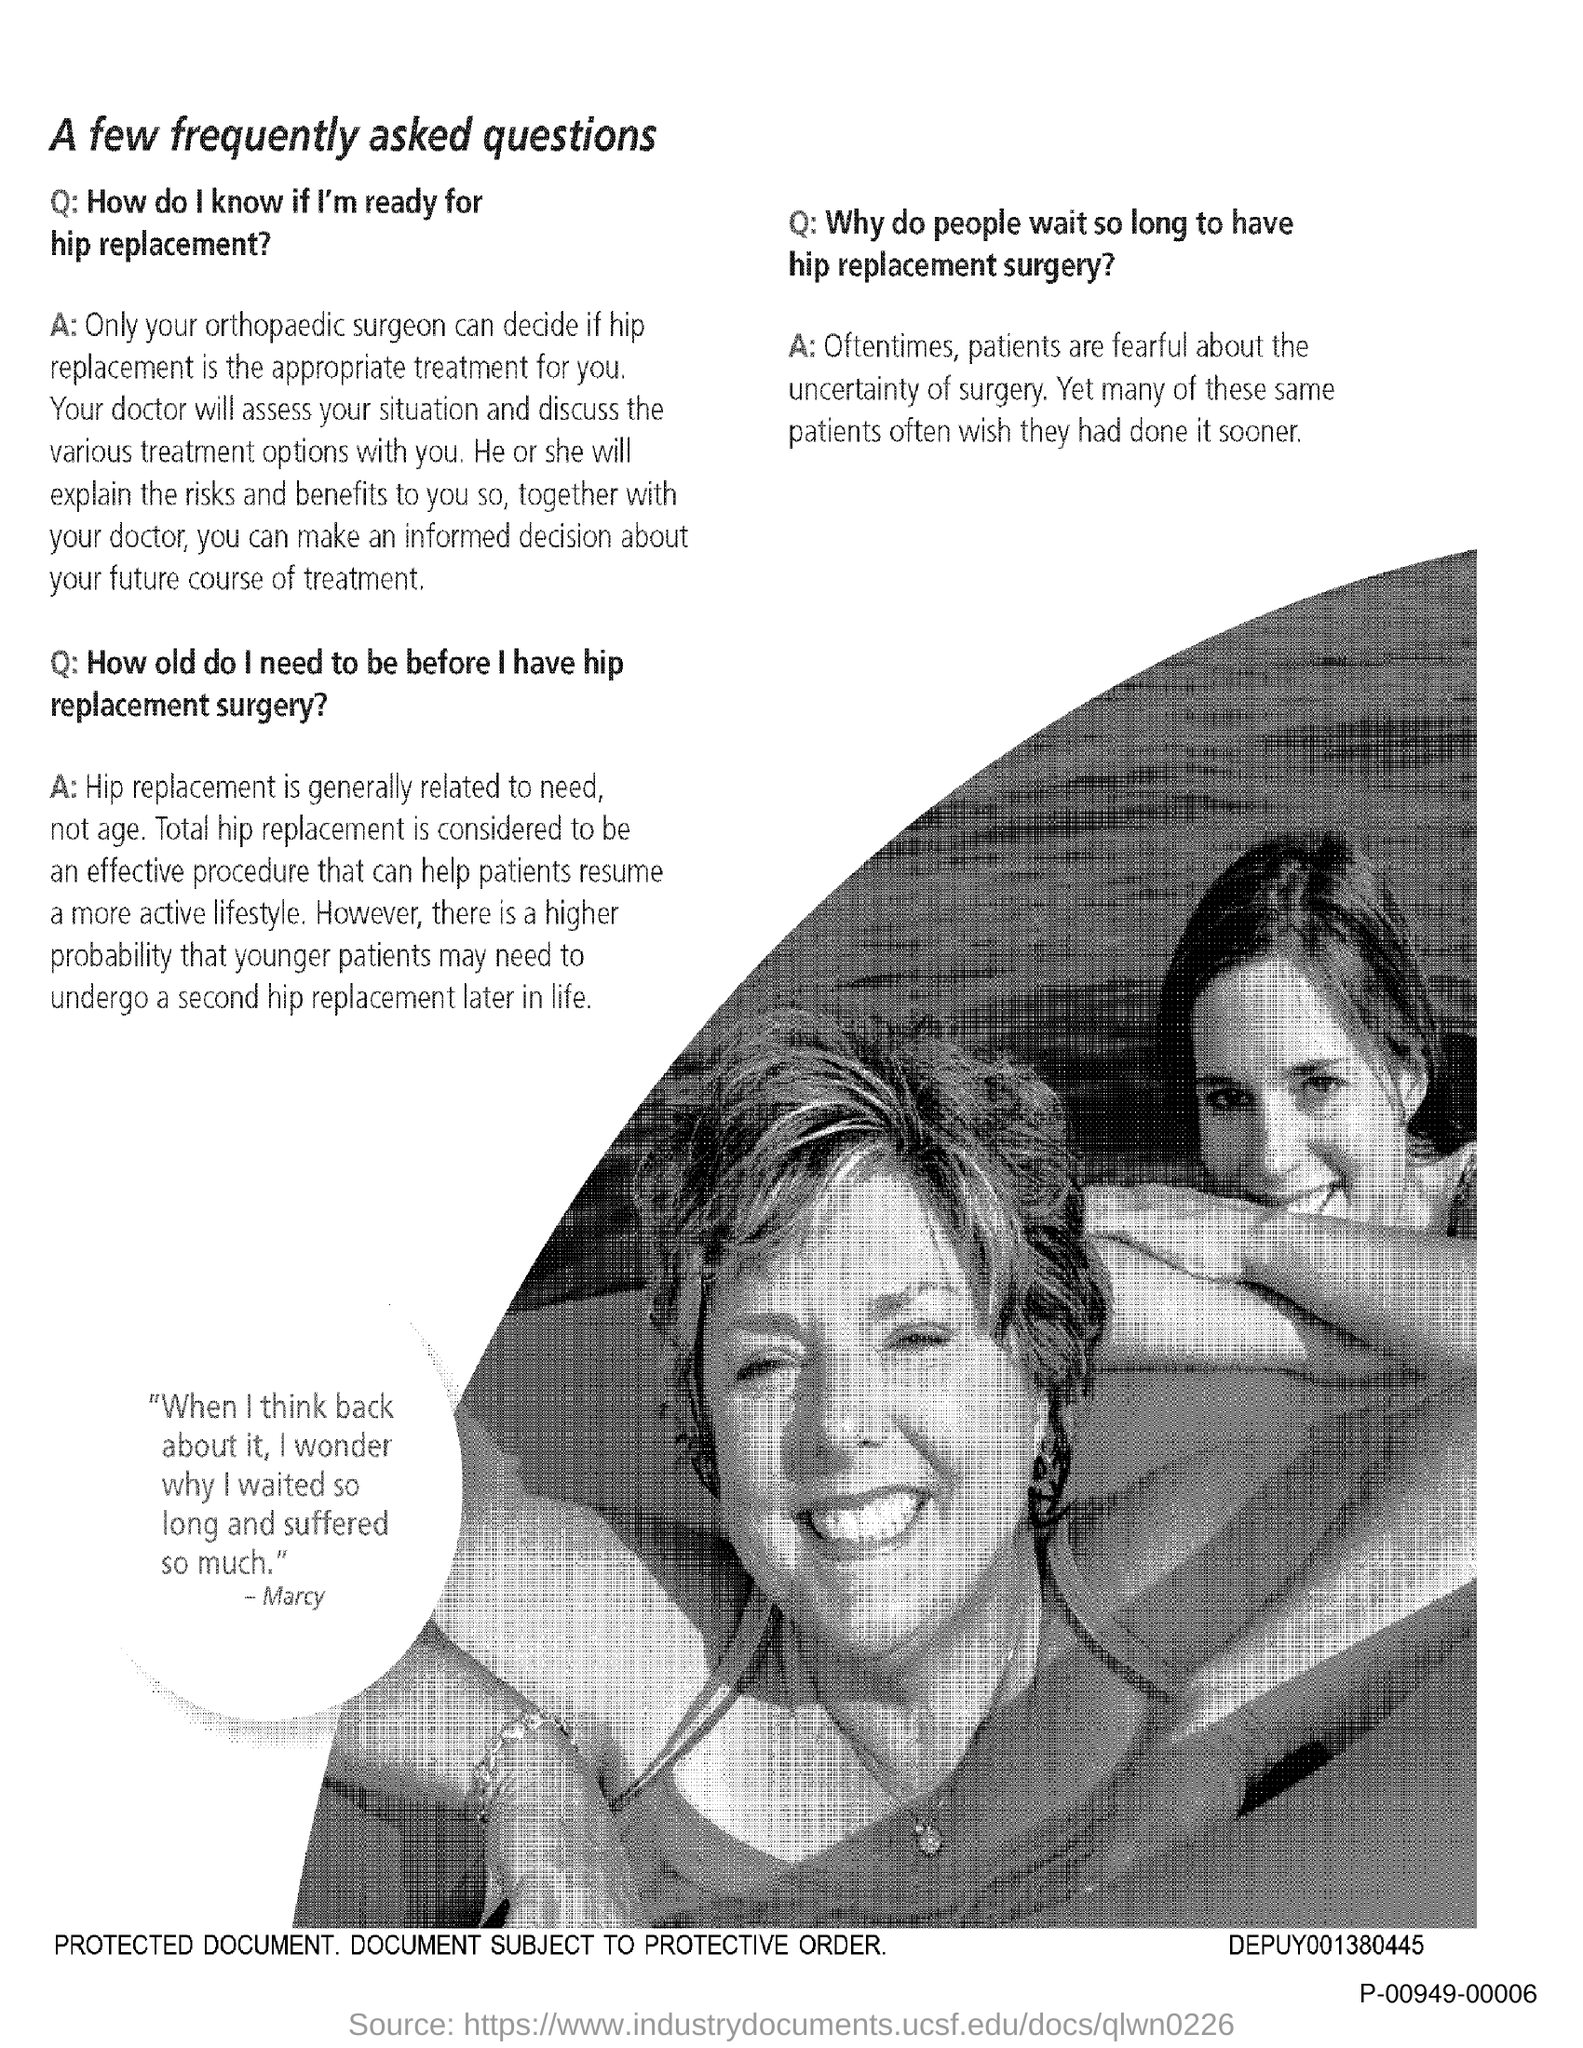What is the title of the document?
Provide a succinct answer. A few frequently asked questions. 